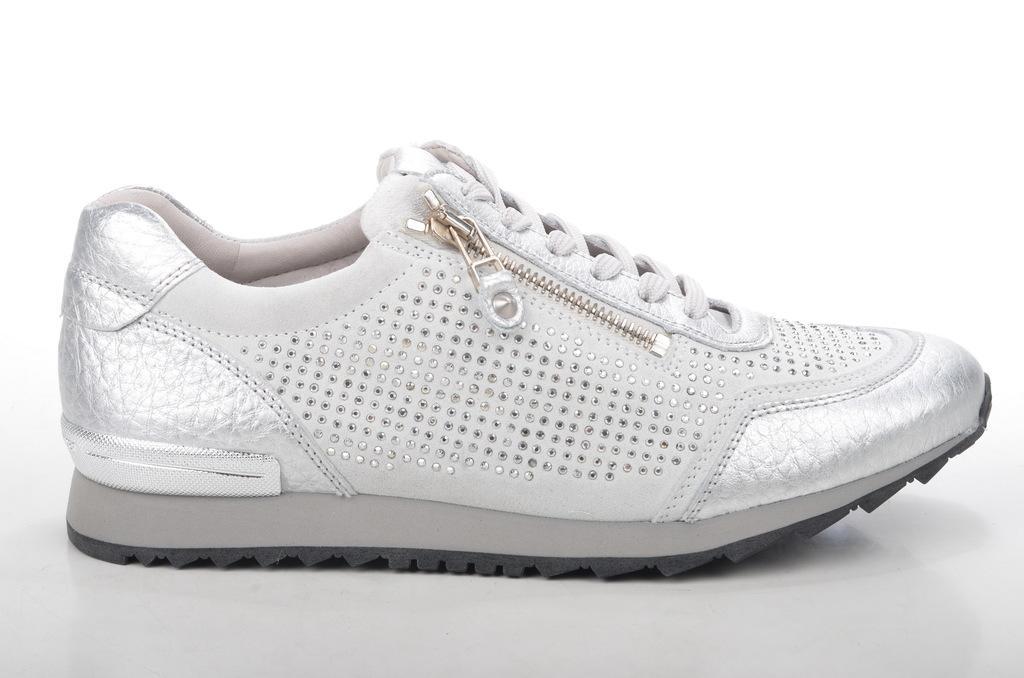Can you describe this image briefly? In this picture i can see a shoe, It is white in color and a zip to it and i can see a white color background. 